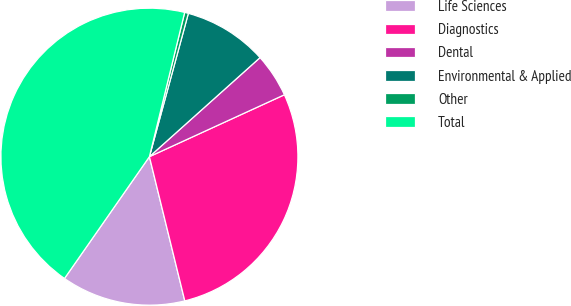Convert chart to OTSL. <chart><loc_0><loc_0><loc_500><loc_500><pie_chart><fcel>Life Sciences<fcel>Diagnostics<fcel>Dental<fcel>Environmental & Applied<fcel>Other<fcel>Total<nl><fcel>13.52%<fcel>28.01%<fcel>4.78%<fcel>9.15%<fcel>0.41%<fcel>44.12%<nl></chart> 